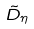Convert formula to latex. <formula><loc_0><loc_0><loc_500><loc_500>\tilde { D } _ { \eta }</formula> 